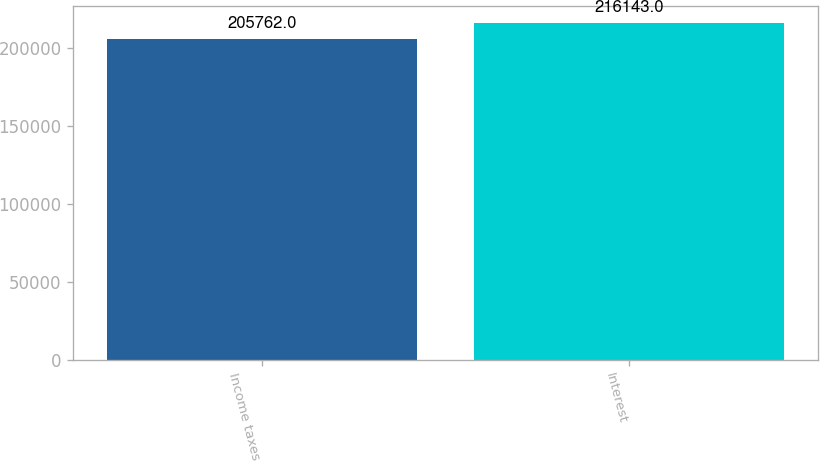Convert chart to OTSL. <chart><loc_0><loc_0><loc_500><loc_500><bar_chart><fcel>Income taxes<fcel>Interest<nl><fcel>205762<fcel>216143<nl></chart> 